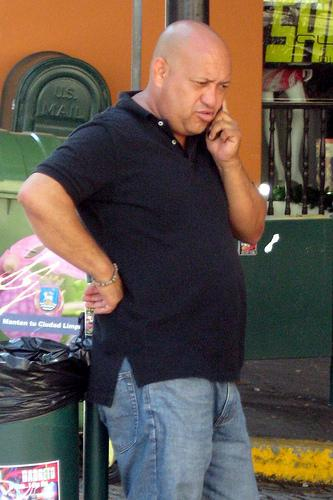Identify an object that indicates a store or business in the image and describe its appearance and location. A yellow sale sign is displayed in the window at the top left corner of the image, indicating a business or store. Please describe the man's appearance and accessories. The man has a bald head and is wearing a blue shirt, blue jeans, and a band on his wrist. Identify the color and type of mailbox present in the background. There is a green US mail box in the background of the image. Describe an object in the image that needs special attention and its location. Focus on the yellow sale sign in the window located at the top left corner of the image. What is the primary focus of the image and what activity are they engaged in? The main focus of the image is a man who is talking on his cell phone. For the visual entailment task, provide a statement about the image and then categorize it as entailed, contradicted, or neutral. Category: Contradicted For the multi-choice VQA task, list a question about the image and provide four possible answers, with one correct answer. Correct answer: c) Blue Create a description for the image that could be used in a product advertisement. Stay connected anytime, anywhere with our latest cell phone model. Communicate effortlessly, even while on the go, just like the man in blue jeans and a blue shirt who talks on his phone in front of a bustling city background. In the image, locate an object with a sticker on it and describe its color and location. A green trash can with a red sticker on it is located at the bottom right corner of the image. 